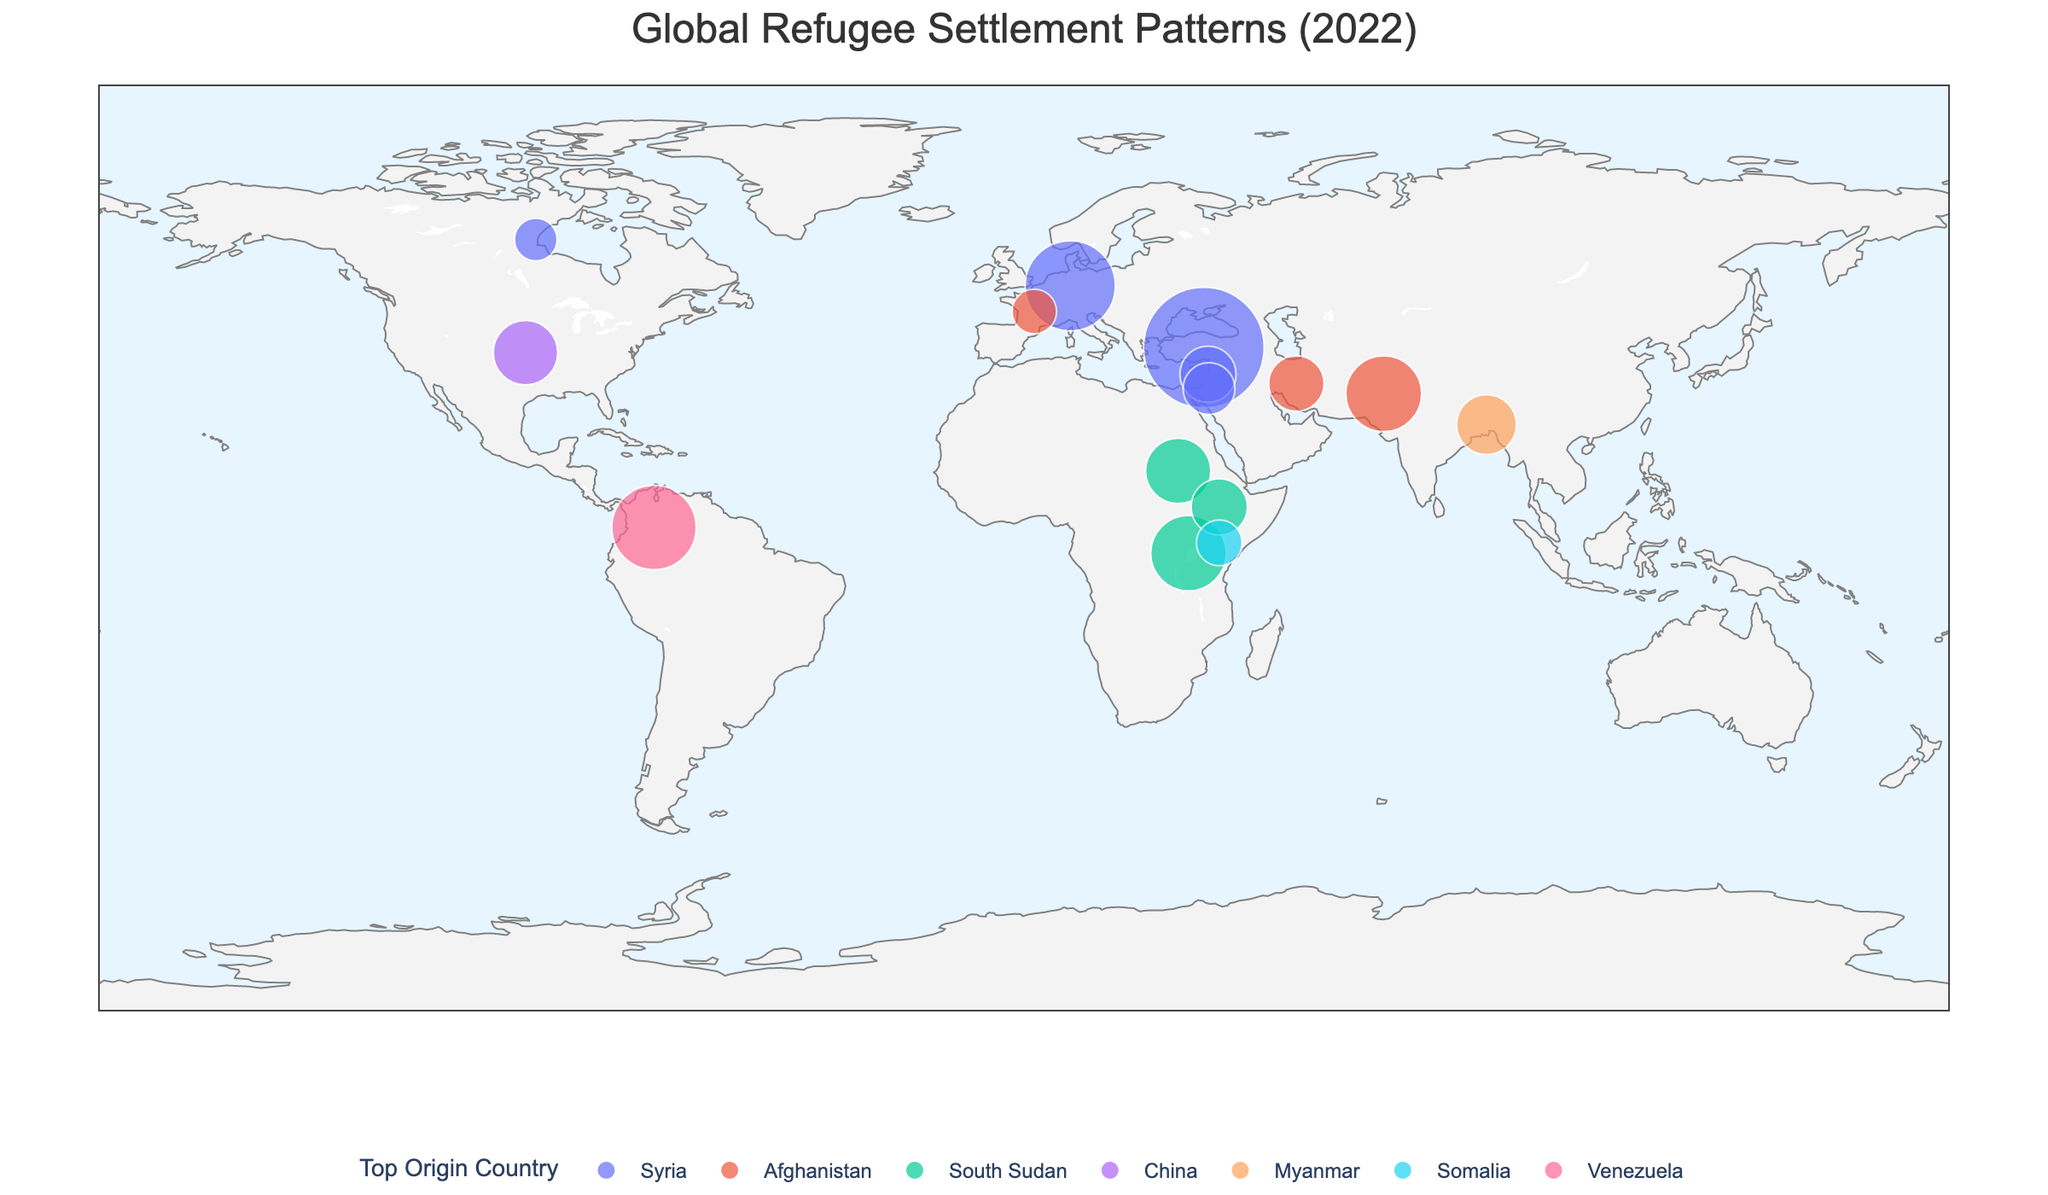What is the title of the figure? The title is usually displayed at the top of the figure, representing the main subject or summary of the plot. Look for prominent text indicating the theme.
Answer: Global Refugee Settlement Patterns (2022) Which country hosts the largest number of refugees according to the plot? Identify the largest bubble on the map and check the associated label or legend that indicates the corresponding country.
Answer: Turkey How many countries have a refugee population exceeding 1 million? Count the number of bubbles with sizes representing more than 1 million refugees.
Answer: 6 What is the top origin country for refugees in Pakistan? Check the legend or the color of Pakistan's bubble on the map to determine the top origin country for refugees settled there.
Answer: Afghanistan Compare the refugee populations between Germany and Uganda. Which country has a higher refugee population? Locate the bubbles representing Germany and Uganda, note their sizes, and compare them directly or refer to the population numbers displayed in the hover information.
Answer: Germany What proportion of total refugee population is hosted by Turkey, Germany, and Pakistan combined? First, add the refugee populations of Turkey, Germany, and Pakistan: 3,759,800 + 2,108,900 + 1,491,100. Then calculate the proportion by assuming this sum as a fraction of the visual total refugee numbers, which needs visual context estimation. Usually, check the detailed data if invisible in the plot.
Answer: Turkey, Germany, and Pakistan host a significant proportion, but exact calculation requires precise total refugee data from the plot or detailed dataset Which country has the most diverse origin countries for refugees? Look at the map for variety in colors of the bubbles and identify which country hosts refugees from multiple origin countries versus a single predominant origin.
Answer: United States or Sudan (requires visual judgement on diversity) In terms of geographic distribution, which continent hosts the most visible refugee populations? Observe the density and size of the bubbles on different continents and determine where the largest clusters appear.
Answer: Asia/Africa Identify two countries from different continents with a similar refugee population size. Find countries on different continents with bubbles of similar sizes and compare the approximate population numbers.
Answer: Uganda and Sudan Is there a visible trend in the origin countries for refugees in Europe? Analyze the colors (top origin countries) of the European countries and identify if there is a predominant country of origin within this region.
Answer: Syria (dominant for Germany and other significant host countries in Europe) 